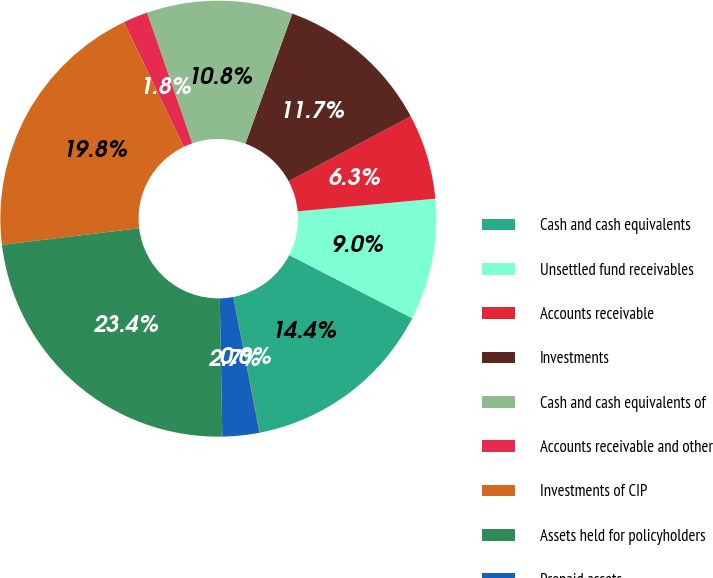Convert chart. <chart><loc_0><loc_0><loc_500><loc_500><pie_chart><fcel>Cash and cash equivalents<fcel>Unsettled fund receivables<fcel>Accounts receivable<fcel>Investments<fcel>Cash and cash equivalents of<fcel>Accounts receivable and other<fcel>Investments of CIP<fcel>Assets held for policyholders<fcel>Prepaid assets<fcel>Other assets<nl><fcel>14.4%<fcel>9.01%<fcel>6.32%<fcel>11.71%<fcel>10.81%<fcel>1.83%<fcel>19.79%<fcel>23.38%<fcel>2.73%<fcel>0.03%<nl></chart> 